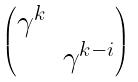<formula> <loc_0><loc_0><loc_500><loc_500>\begin{pmatrix} \gamma ^ { k } & \\ & \gamma ^ { k - i } \\ \end{pmatrix}</formula> 